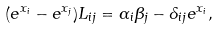Convert formula to latex. <formula><loc_0><loc_0><loc_500><loc_500>( e ^ { x _ { i } } - e ^ { x _ { j } } ) L _ { i j } = \alpha _ { i } \beta _ { j } - \delta _ { i j } e ^ { x _ { i } } ,</formula> 